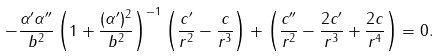Convert formula to latex. <formula><loc_0><loc_0><loc_500><loc_500>- \frac { \alpha ^ { \prime } \alpha ^ { \prime \prime } } { b ^ { 2 } } \left ( 1 + \frac { ( \alpha ^ { \prime } ) ^ { 2 } } { b ^ { 2 } } \right ) ^ { - 1 } \left ( \frac { c ^ { \prime } } { r ^ { 2 } } - \frac { c } { r ^ { 3 } } \right ) + \left ( \frac { c ^ { \prime \prime } } { r ^ { 2 } } - \frac { 2 c ^ { \prime } } { r ^ { 3 } } + \frac { 2 c } { r ^ { 4 } } \right ) = 0 .</formula> 